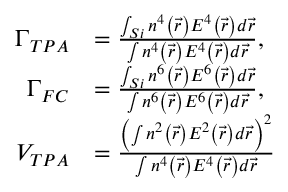Convert formula to latex. <formula><loc_0><loc_0><loc_500><loc_500>\begin{array} { r l } { \Gamma _ { T P A } } & { = \frac { \int _ { S i } n ^ { 4 } \left ( \vec { r } \right ) E ^ { 4 } \left ( \vec { r } \right ) d \vec { r } } { \int n ^ { 4 } \left ( \vec { r } \right ) E ^ { 4 } \left ( \vec { r } \right ) d \vec { r } } , } \\ { \Gamma _ { F C } } & { = \frac { \int _ { S i } n ^ { 6 } \left ( \vec { r } \right ) E ^ { 6 } \left ( \vec { r } \right ) d \vec { r } } { \int n ^ { 6 } \left ( \vec { r } \right ) E ^ { 6 } \left ( \vec { r } \right ) d \vec { r } } , } \\ { V _ { T P A } } & { = \frac { \left ( \int n ^ { 2 } \left ( \vec { r } \right ) E ^ { 2 } \left ( \vec { r } \right ) d \vec { r } \right ) ^ { 2 } } { \int n ^ { 4 } \left ( \vec { r } \right ) E ^ { 4 } \left ( \vec { r } \right ) d \vec { r } } } \end{array}</formula> 